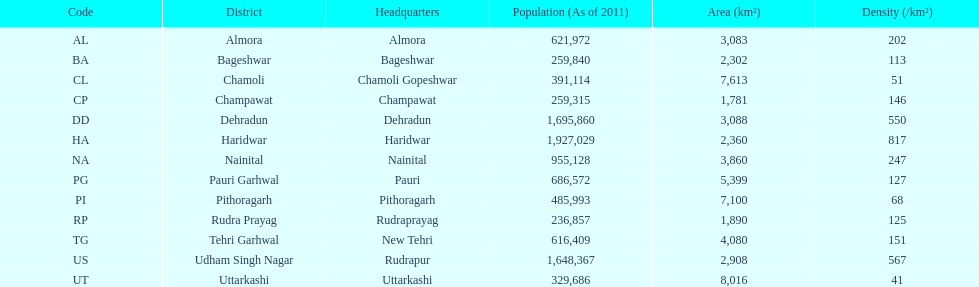What is the cumulative count of districts listed? 13. 